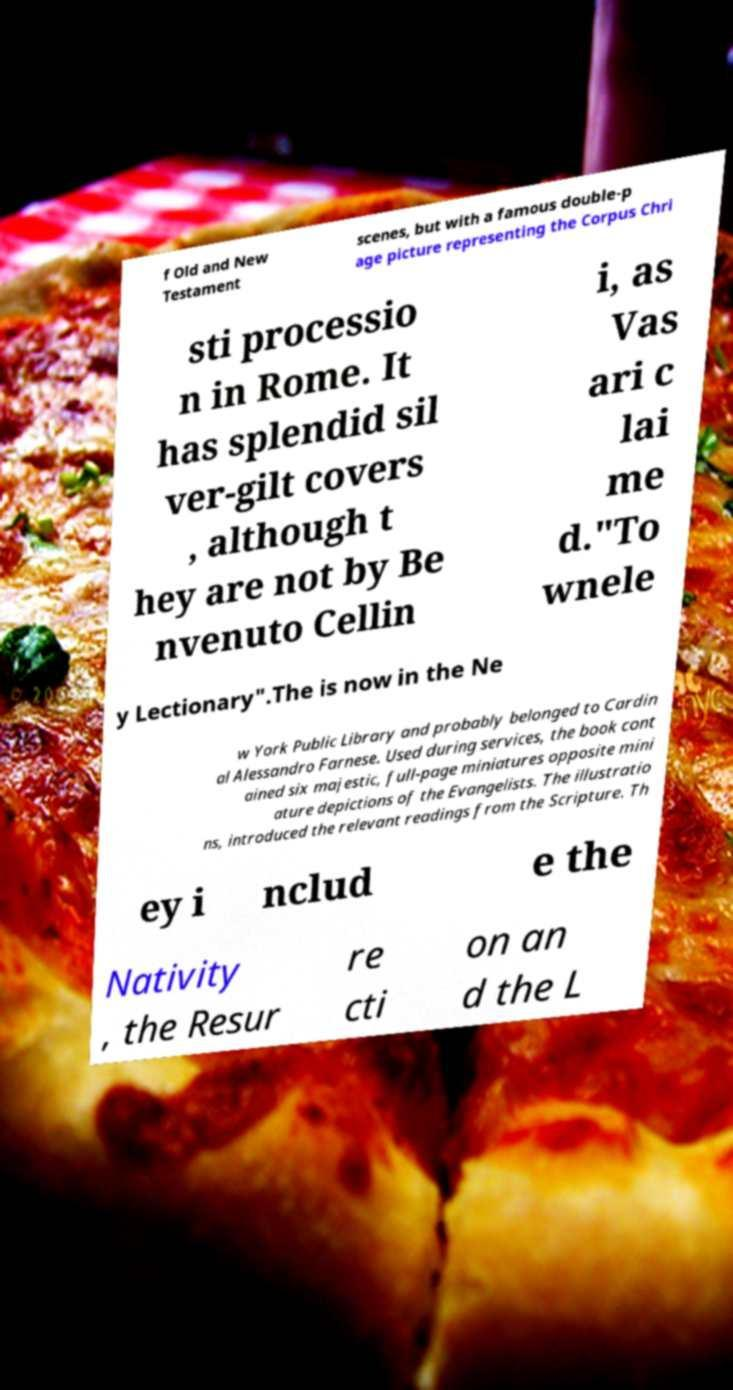Please identify and transcribe the text found in this image. f Old and New Testament scenes, but with a famous double-p age picture representing the Corpus Chri sti processio n in Rome. It has splendid sil ver-gilt covers , although t hey are not by Be nvenuto Cellin i, as Vas ari c lai me d."To wnele y Lectionary".The is now in the Ne w York Public Library and probably belonged to Cardin al Alessandro Farnese. Used during services, the book cont ained six majestic, full-page miniatures opposite mini ature depictions of the Evangelists. The illustratio ns, introduced the relevant readings from the Scripture. Th ey i nclud e the Nativity , the Resur re cti on an d the L 